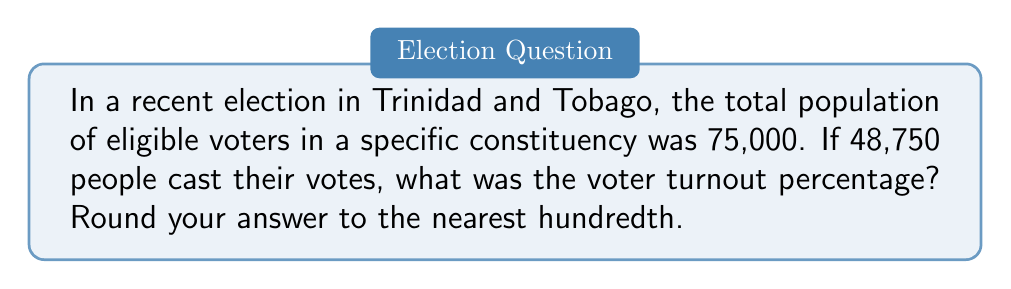Show me your answer to this math problem. To calculate the voter turnout percentage, we need to divide the number of people who voted by the total number of eligible voters and then multiply by 100 to convert to a percentage.

Let's define our variables:
$T$ = Total eligible voters = 75,000
$V$ = Number of votes cast = 48,750

The formula for voter turnout percentage is:

$$ \text{Voter Turnout Percentage} = \frac{V}{T} \times 100\% $$

Substituting our values:

$$ \text{Voter Turnout Percentage} = \frac{48,750}{75,000} \times 100\% $$

Simplifying:

$$ \text{Voter Turnout Percentage} = 0.65 \times 100\% = 65\% $$

Therefore, the voter turnout percentage is exactly 65%.

Since the question asks to round to the nearest hundredth, our final answer remains 65.00%.
Answer: 65.00% 